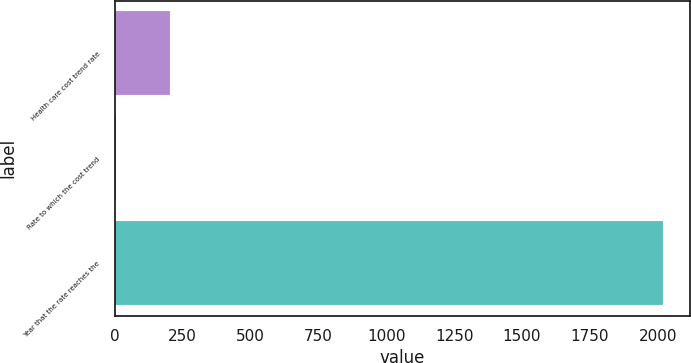<chart> <loc_0><loc_0><loc_500><loc_500><bar_chart><fcel>Health care cost trend rate<fcel>Rate to which the cost trend<fcel>Year that the rate reaches the<nl><fcel>205.85<fcel>4.5<fcel>2018<nl></chart> 